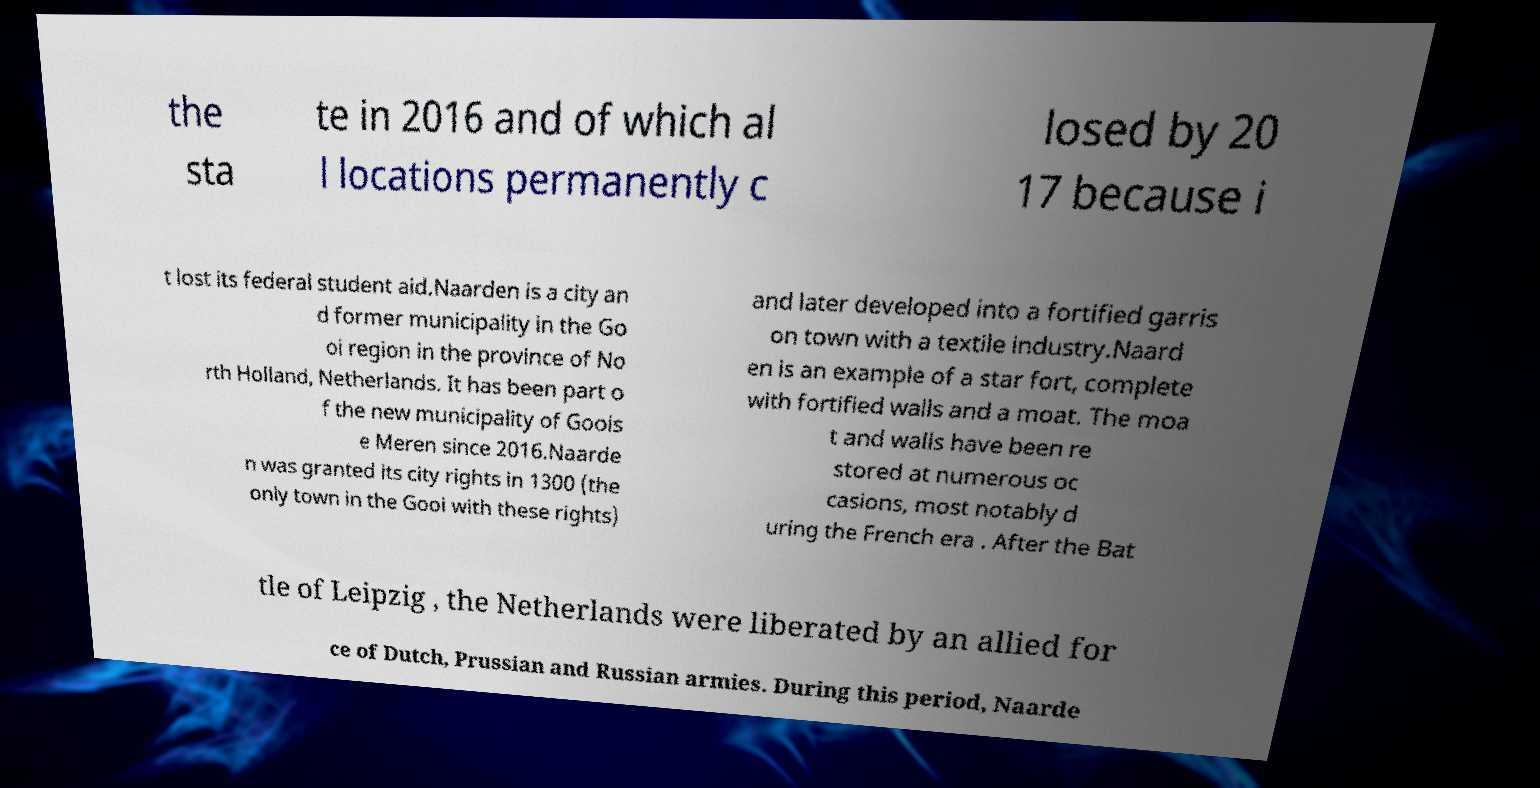There's text embedded in this image that I need extracted. Can you transcribe it verbatim? the sta te in 2016 and of which al l locations permanently c losed by 20 17 because i t lost its federal student aid.Naarden is a city an d former municipality in the Go oi region in the province of No rth Holland, Netherlands. It has been part o f the new municipality of Goois e Meren since 2016.Naarde n was granted its city rights in 1300 (the only town in the Gooi with these rights) and later developed into a fortified garris on town with a textile industry.Naard en is an example of a star fort, complete with fortified walls and a moat. The moa t and walls have been re stored at numerous oc casions, most notably d uring the French era . After the Bat tle of Leipzig , the Netherlands were liberated by an allied for ce of Dutch, Prussian and Russian armies. During this period, Naarde 